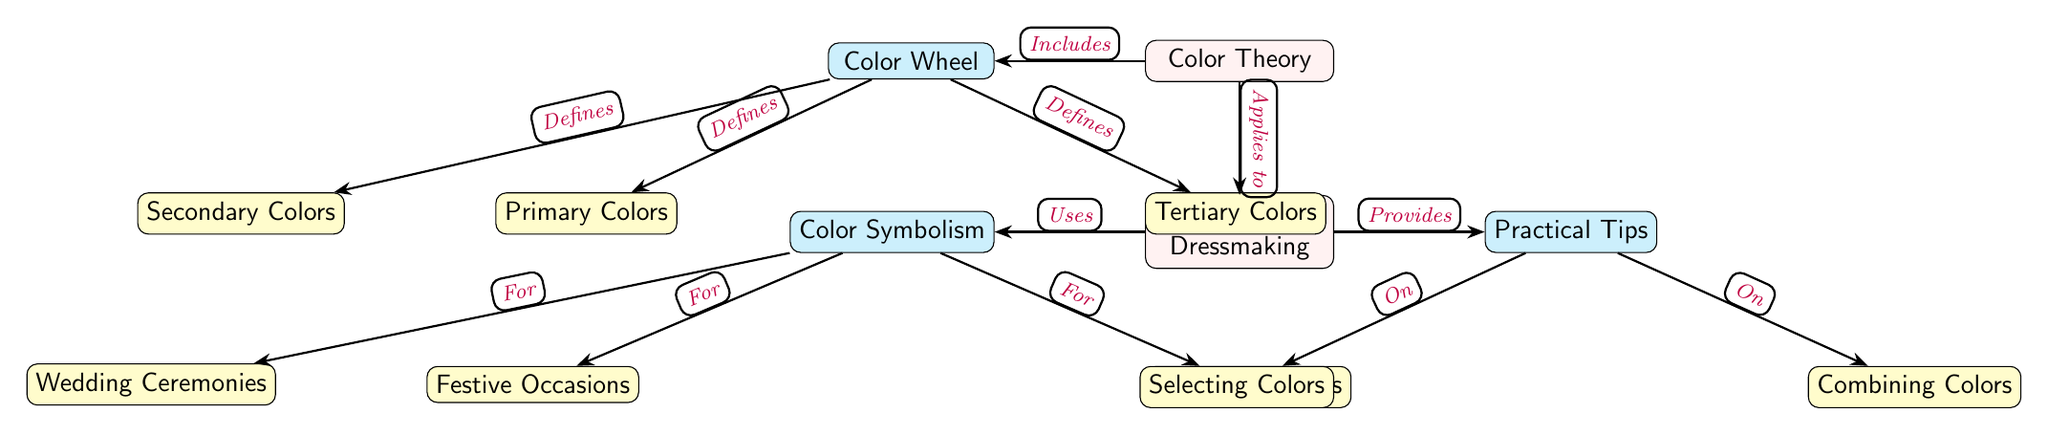What are the three main categories of color in the color wheel? The diagram indicates that the primary, secondary, and tertiary colors are the three main categories under the color wheel.
Answer: Primary Colors, Secondary Colors, Tertiary Colors What occasions does color symbolism apply to in traditional dressmaking? From the diagram, color symbolism is shown to apply to festive occasions, wedding ceremonies, and mourning events, as indicated by the connections under the color symbolism node.
Answer: Festive Occasions, Wedding Ceremonies, Mourning Events How does color theory relate to traditional dressmaking? The diagram illustrates that color theory applies to traditional dressmaking, as indicated by the connection from the color theory node to the traditional dressmaking node.
Answer: Applies to What are the two main practical tips provided under traditional dressmaking? The diagram displays that selecting colors and combining colors are the two practical tips listed under the traditional dressmaking section, represented by the practical tips node.
Answer: Selecting Colors, Combining Colors How many sub-nodes does the diagram have in total? The diagram consists of 8 sub-nodes (3 under color wheel, 3 under color symbolism, and 2 under practical tips), therefore counting each individual sub-node gives a total of 8.
Answer: 8 What defines secondary colors in the color wheel? The diagram shows that secondary colors are defined as one of the main categories of colors that stem from the color wheel, connecting the color wheel node to secondary colors.
Answer: Defines Which node directly follows color symbolism for mourning events? In the diagram, mourning events follows color symbolism directly, as indicated by the connection from color symbolism node to mourning events node and is shown in the flow of relationships in the diagram.
Answer: Mourning Events What visual element connects practical tips to selecting colors? The diagram connects practical tips to selecting colors with a directed edge labeled "On," indicating that these tips specifically relate to selecting colors in the context of traditional dressmaking.
Answer: On 